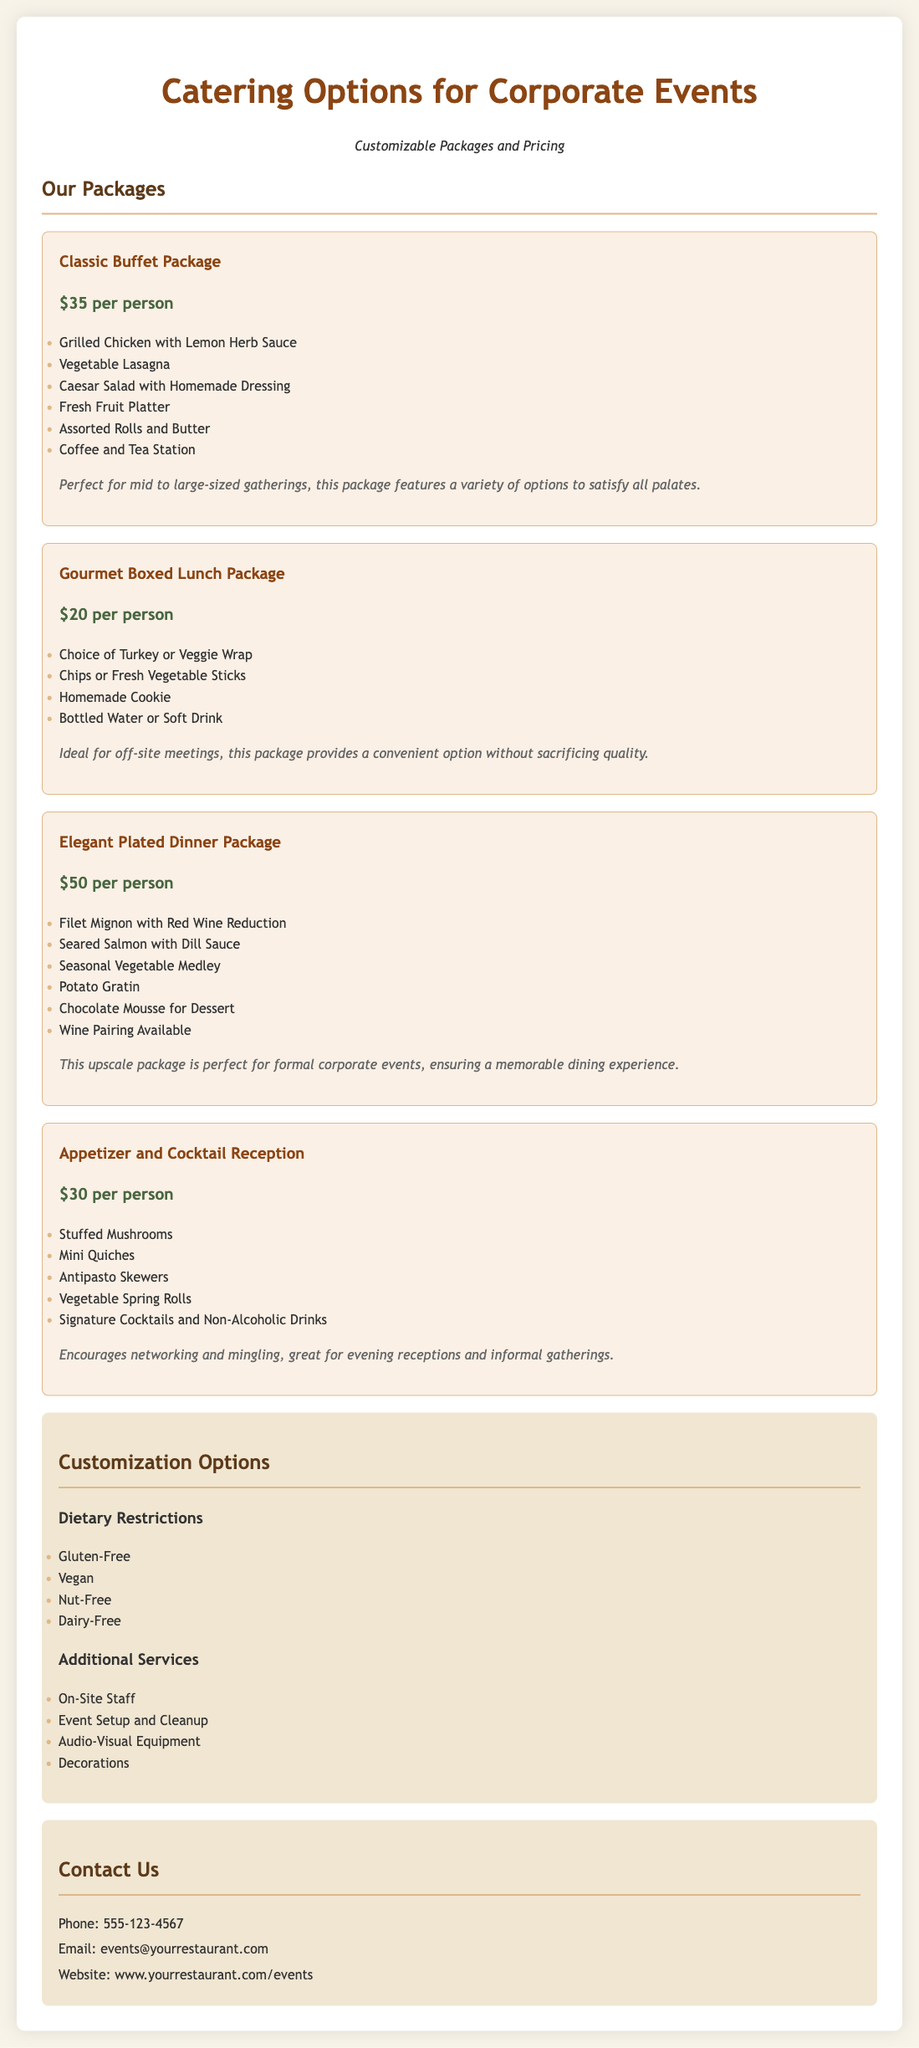What is the price of the Classic Buffet Package? The price of the Classic Buffet Package is listed as $35 per person.
Answer: $35 per person How many packages are listed in the document? There are four distinct packages offered in the document.
Answer: Four What dietary options are available for customization? The document lists four dietary options for customization: Gluten-Free, Vegan, Nut-Free, and Dairy-Free.
Answer: Gluten-Free, Vegan, Nut-Free, Dairy-Free Which package is ideal for off-site meetings? The Gourmet Boxed Lunch Package is mentioned as ideal for off-site meetings.
Answer: Gourmet Boxed Lunch Package What type of dessert is included in the Elegant Plated Dinner Package? The dessert included in the Elegant Plated Dinner Package is Chocolate Mousse.
Answer: Chocolate Mousse How many items are included in the Appetizer and Cocktail Reception package? The Appetizer and Cocktail Reception package includes five items as listed in the document.
Answer: Five items 